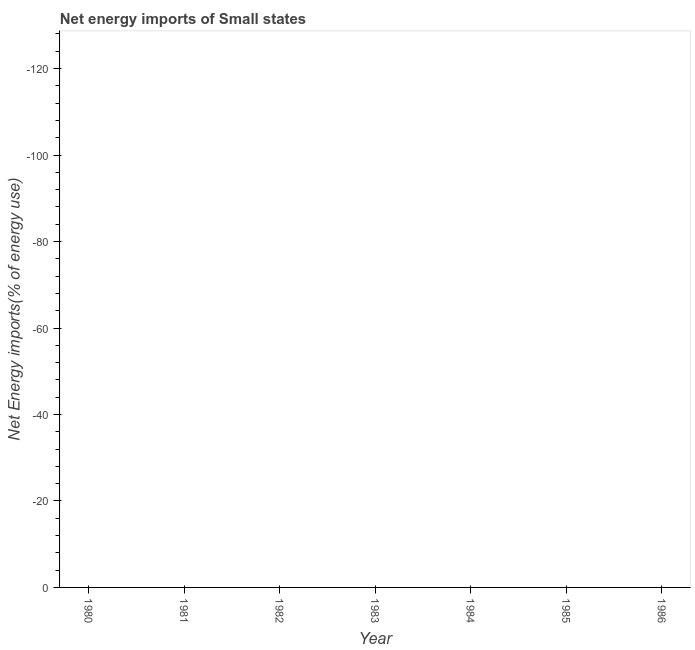What is the energy imports in 1982?
Give a very brief answer. 0. What is the average energy imports per year?
Offer a terse response. 0. In how many years, is the energy imports greater than -60 %?
Give a very brief answer. 0. In how many years, is the energy imports greater than the average energy imports taken over all years?
Keep it short and to the point. 0. Does the energy imports monotonically increase over the years?
Your answer should be compact. No. How many years are there in the graph?
Offer a terse response. 7. What is the difference between two consecutive major ticks on the Y-axis?
Your response must be concise. 20. Does the graph contain grids?
Offer a terse response. No. What is the title of the graph?
Keep it short and to the point. Net energy imports of Small states. What is the label or title of the Y-axis?
Offer a terse response. Net Energy imports(% of energy use). What is the Net Energy imports(% of energy use) of 1981?
Keep it short and to the point. 0. What is the Net Energy imports(% of energy use) in 1985?
Keep it short and to the point. 0. What is the Net Energy imports(% of energy use) of 1986?
Ensure brevity in your answer.  0. 